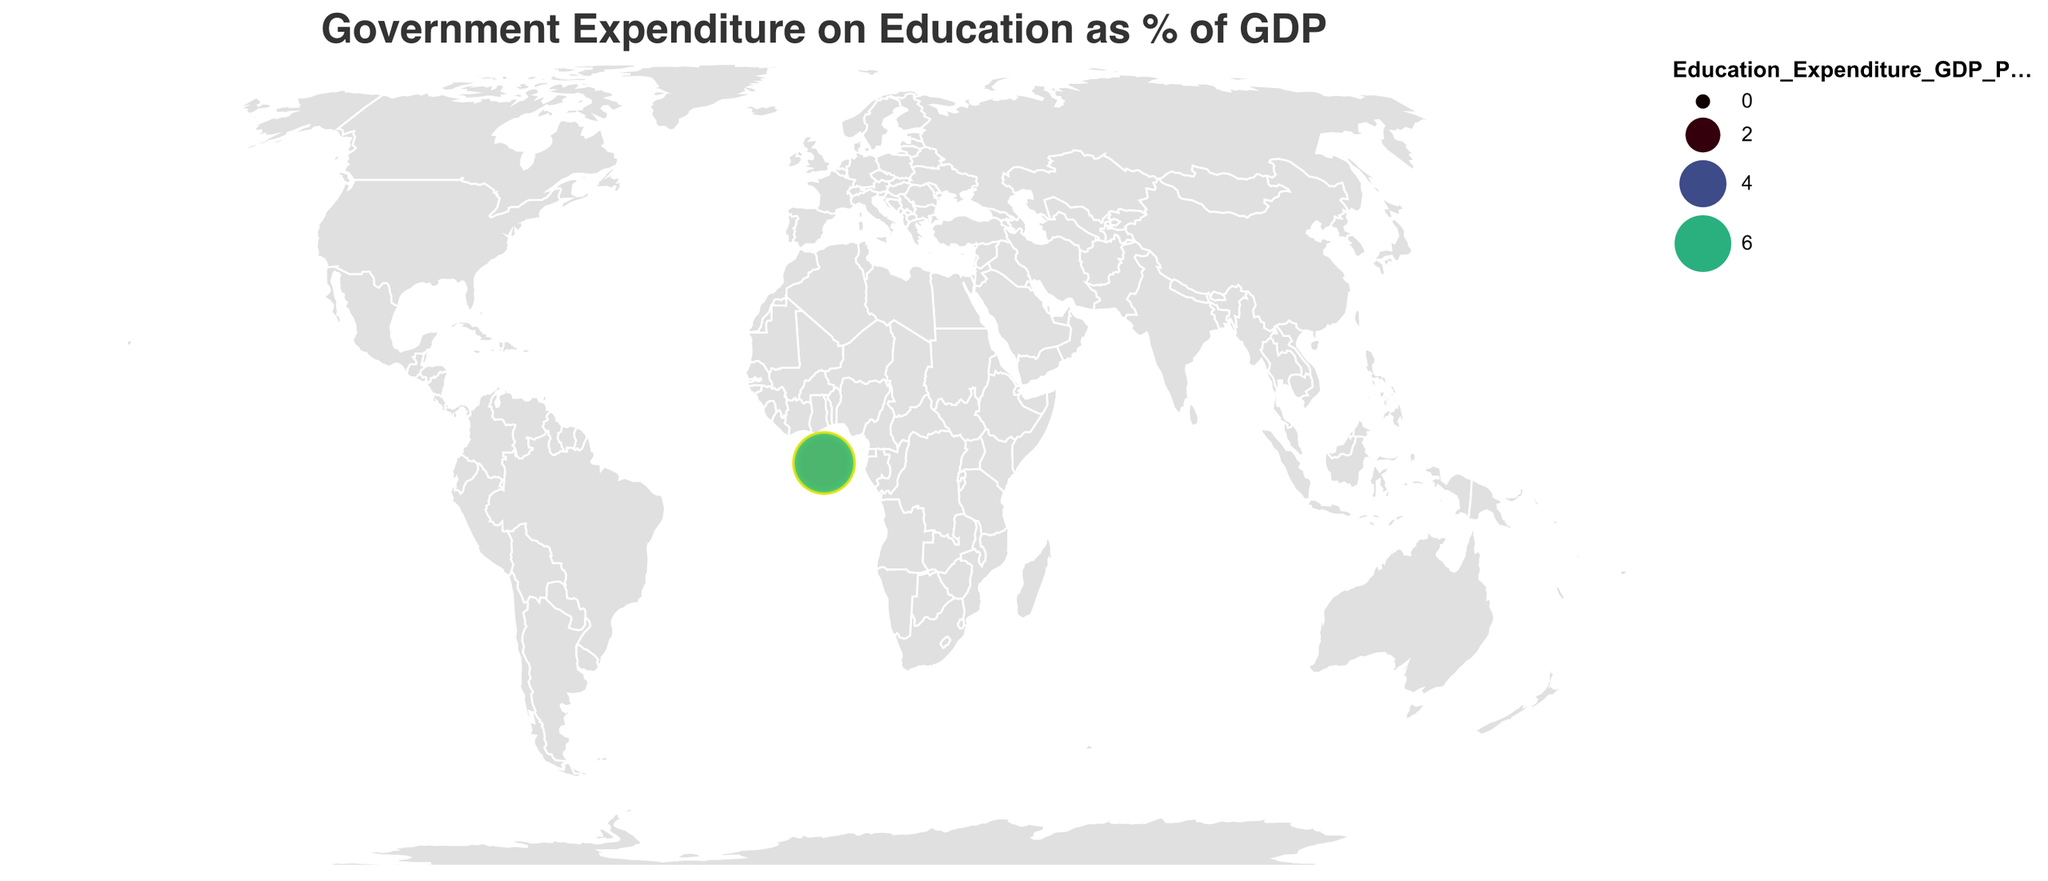What's the title of the plot? The title of the plot is displayed at the top center of the figure and reads "Government Expenditure on Education as % of GDP".
Answer: Government Expenditure on Education as % of GDP Which country has the highest government expenditure on education as a percentage of GDP? The largest circle and the highest intensity of color can be observed for Denmark on the map. Its value as given in the data is 7.8%.
Answer: Denmark What is the government expenditure on education as a percentage of GDP for the United States? By locating the United States on the map, we can refer to the tooltip or the corresponding circle size and color. The value given in the data is 5.0%.
Answer: 5.0% Which country spends the least on education as a percentage of GDP? The smallest circle with the least intense color is for Singapore. Its value as given in the data is 2.9%.
Answer: Singapore What is the difference in education expenditure between Norway and Japan? From the data, Norway spends 7.6% and Japan spends 3.5% on education. The difference is calculated as 7.6% - 3.5%.
Answer: 4.1% Which countries spend more than 6% of their GDP on education? Referring to the data, the countries that spend more than 6% include Norway (7.6%), Denmark (7.8%), Sweden (7.1%), Finland (6.4%), Iceland (7.5%), New Zealand (6.3%), Brazil (6.1%), and South Africa (6.5%).
Answer: Norway, Denmark, Sweden, Finland, Iceland, New Zealand, Brazil, South Africa Compare the education expenditure in percentage of GDP between Finland and South Africa. Which country spends more? From the data, Finland spends 6.4% and South Africa spends 6.5%. Hence, South Africa spends slightly more.
Answer: South Africa What is the average government expenditure on education as a percentage of GDP for all countries listed? Sum all the expenditure percentages: (7.6 + 7.8 + 7.1 + 6.4 + 7.5 + 6.3 + 5.3 + 5.5 + 5.4 + 5.1 + 5.0 + 4.9 + 5.5 + 3.5 + 4.6 + 2.9 + 4.0 + 3.8 + 6.1 + 6.5) = 110.2. There are 20 countries, so the average is 110.2 / 20.
Answer: 5.51 